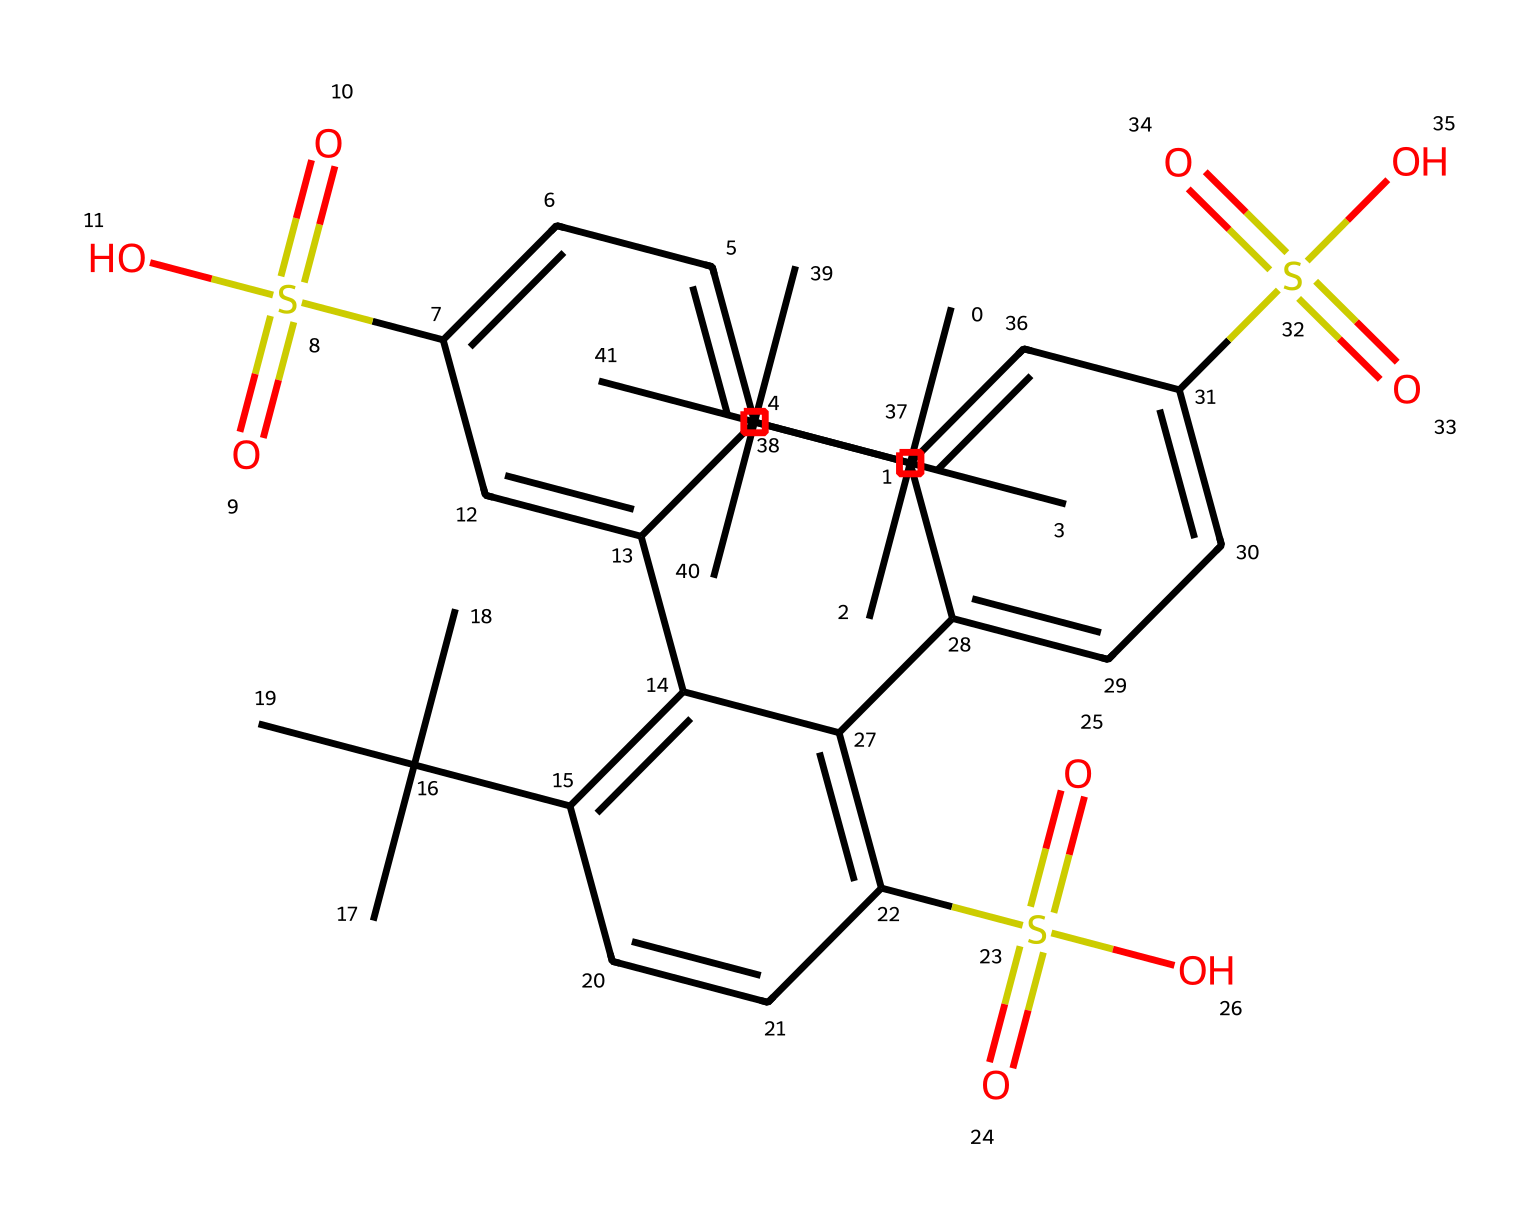What is the functional group present in this compound? The structural representation indicates that we have sulfonic acid groups (S(=O)(=O)O), which are characterized by a sulfur atom bonded to three oxygen atoms. This functional group is relevant in the context of proton exchange membranes in fuel cells.
Answer: sulfonic acid How many benzene rings are present in this structure? By analyzing the SMILES representation, there are distinct sections that have the aromatic system, and upon counting them, there are a total of four benzene rings present in the structure.
Answer: four What is the molecular weight impact of the bulky tert-butyl groups? The presence of the tert-butyl groups contributes significantly to the molecular weight due to their size and saturation. Examining their structure shows they each consist of four carbon atoms and nine hydrogens (C4H9), which adds considerable mass.
Answer: increases What type of polymer backbone is indicated by this structure? The presence of repeating sulfonic acid functional groups along with the hydrocarbon chains suggests that this compound is a type of sulfonated polymer with an aromatic backbone, commonly found in fuel cell membranes.
Answer: sulfonated polymer Which aspect of this polymer makes it suitable for proton conduction? The presence of sulfonic acid groups creates sites for protonation, enabling proton conduction through the polymer electrolyte membrane. This mechanism enhances the performance of the fuel cell by providing a pathway for protons to travel from the anode to the cathode.
Answer: sulfonic acid groups 